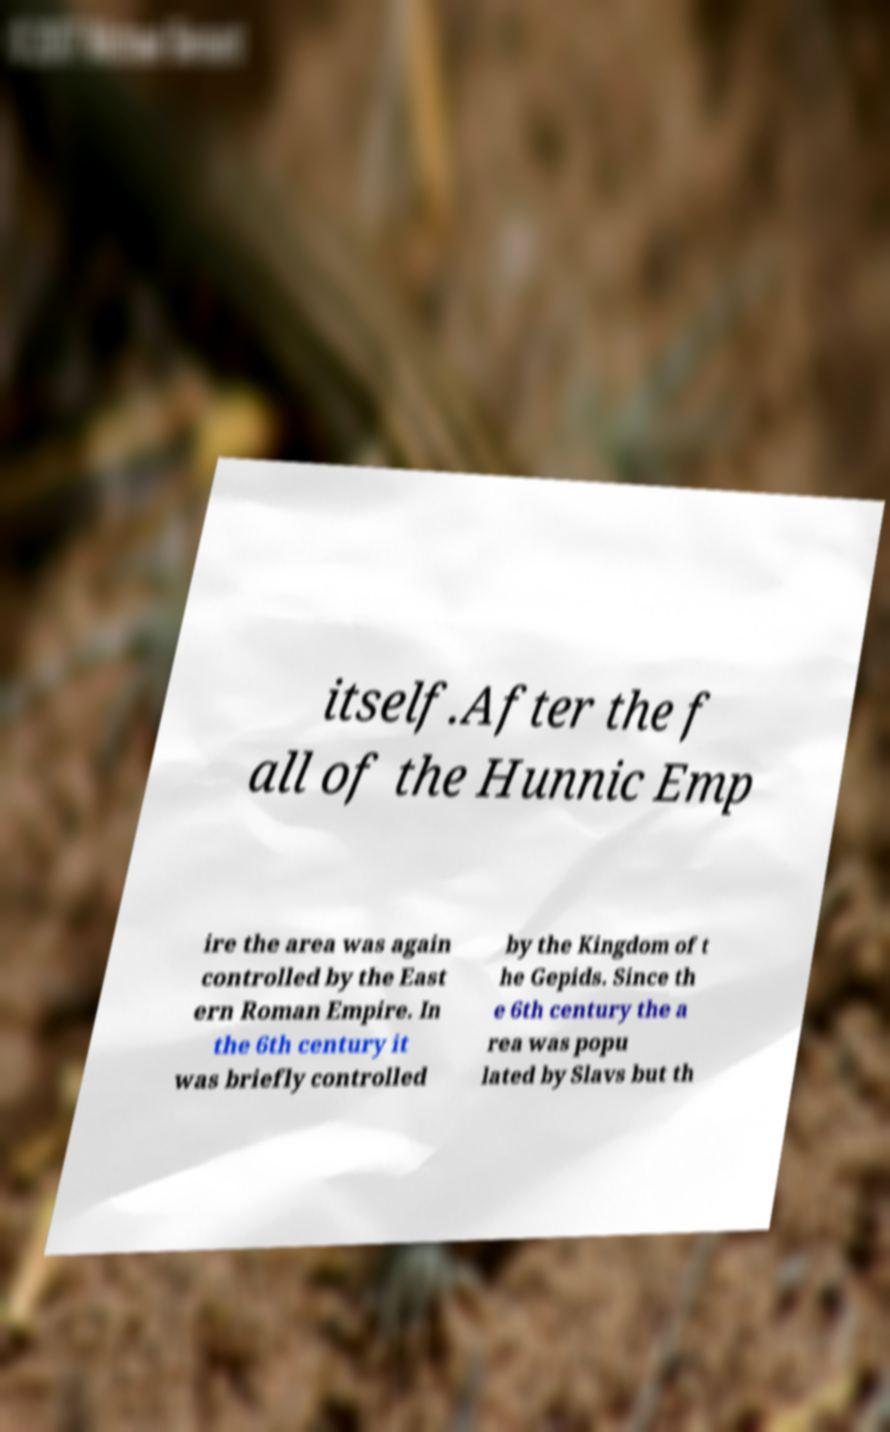Please read and relay the text visible in this image. What does it say? itself.After the f all of the Hunnic Emp ire the area was again controlled by the East ern Roman Empire. In the 6th century it was briefly controlled by the Kingdom of t he Gepids. Since th e 6th century the a rea was popu lated by Slavs but th 